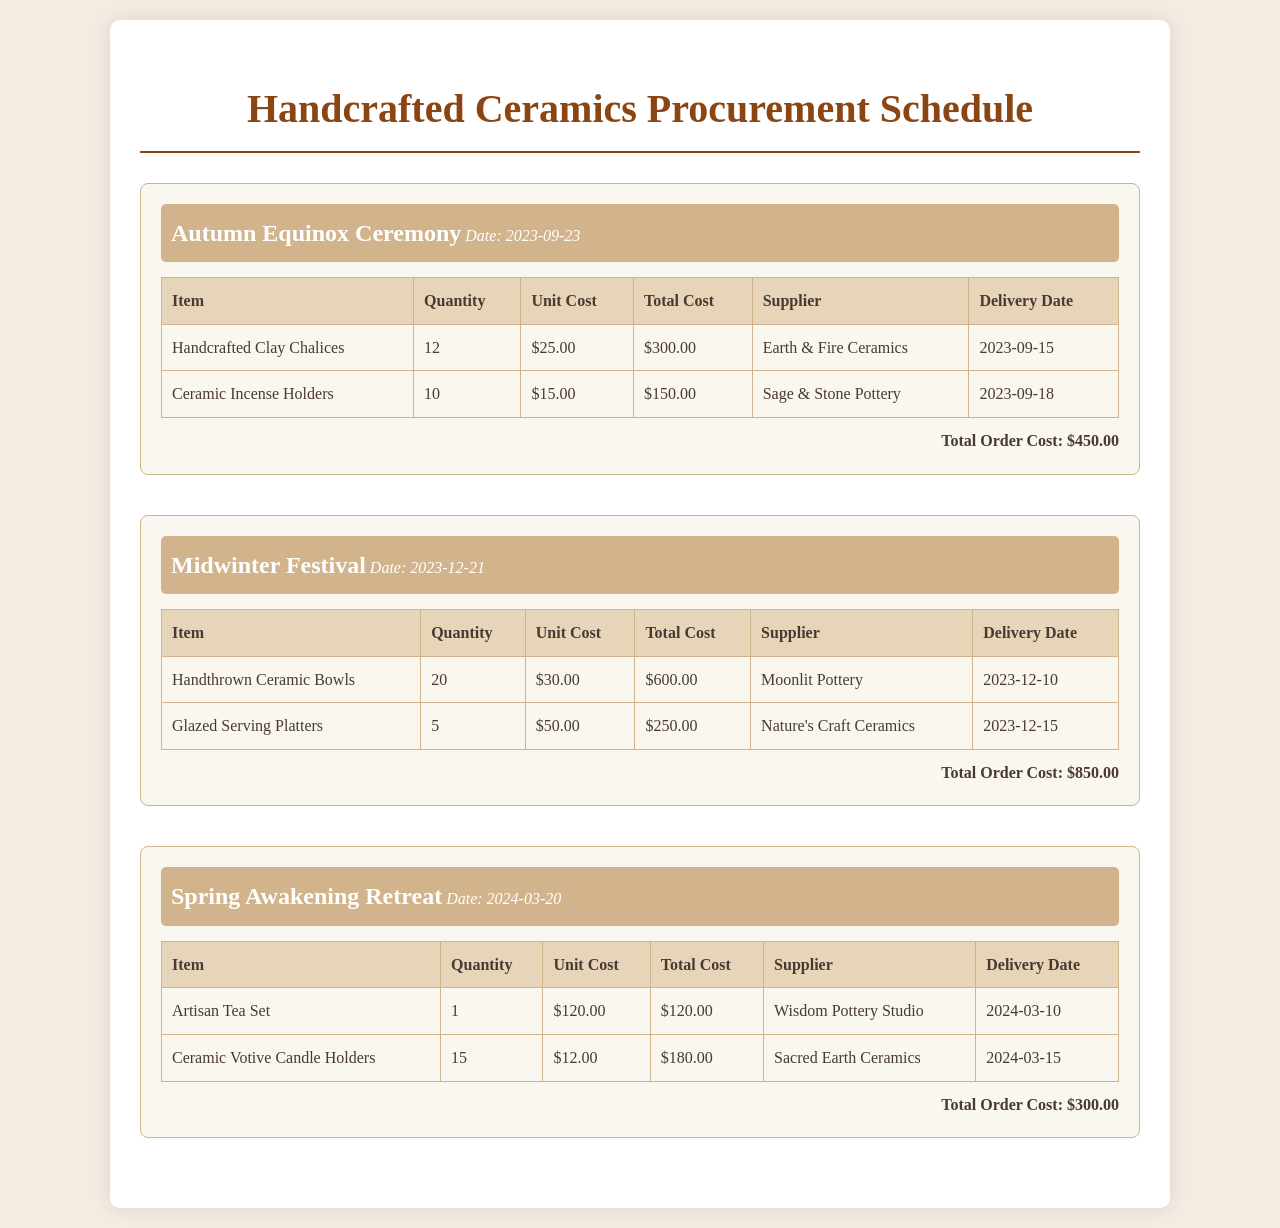What is the date of the Autumn Equinox Ceremony? The date of the Autumn Equinox Ceremony is clearly mentioned in the document as 2023-09-23.
Answer: 2023-09-23 What is the total cost for the Midwinter Festival order? The total cost for the Midwinter Festival order is specifically listed in the document as $850.00.
Answer: $850.00 Who is the supplier for the Handcrafted Clay Chalices? The supplier for the Handcrafted Clay Chalices is detailed in the document as Earth & Fire Ceramics.
Answer: Earth & Fire Ceramics What item has a delivery date of 2024-03-10? The item with a delivery date of 2024-03-10 is noted in the document as the Artisan Tea Set.
Answer: Artisan Tea Set How many Ceramic Incense Holders are being ordered? The document indicates that 10 Ceramic Incense Holders are being ordered.
Answer: 10 What is the quantity of Glazed Serving Platters needed? According to the document, the quantity of Glazed Serving Platters needed is 5.
Answer: 5 What is the total order cost for the Spring Awakening Retreat? The total order cost for the Spring Awakening Retreat is listed as $300.00 in the document.
Answer: $300.00 What item is being procured from Nature's Craft Ceramics? The item being procured from Nature's Craft Ceramics is stated as Glazed Serving Platters in the document.
Answer: Glazed Serving Platters 